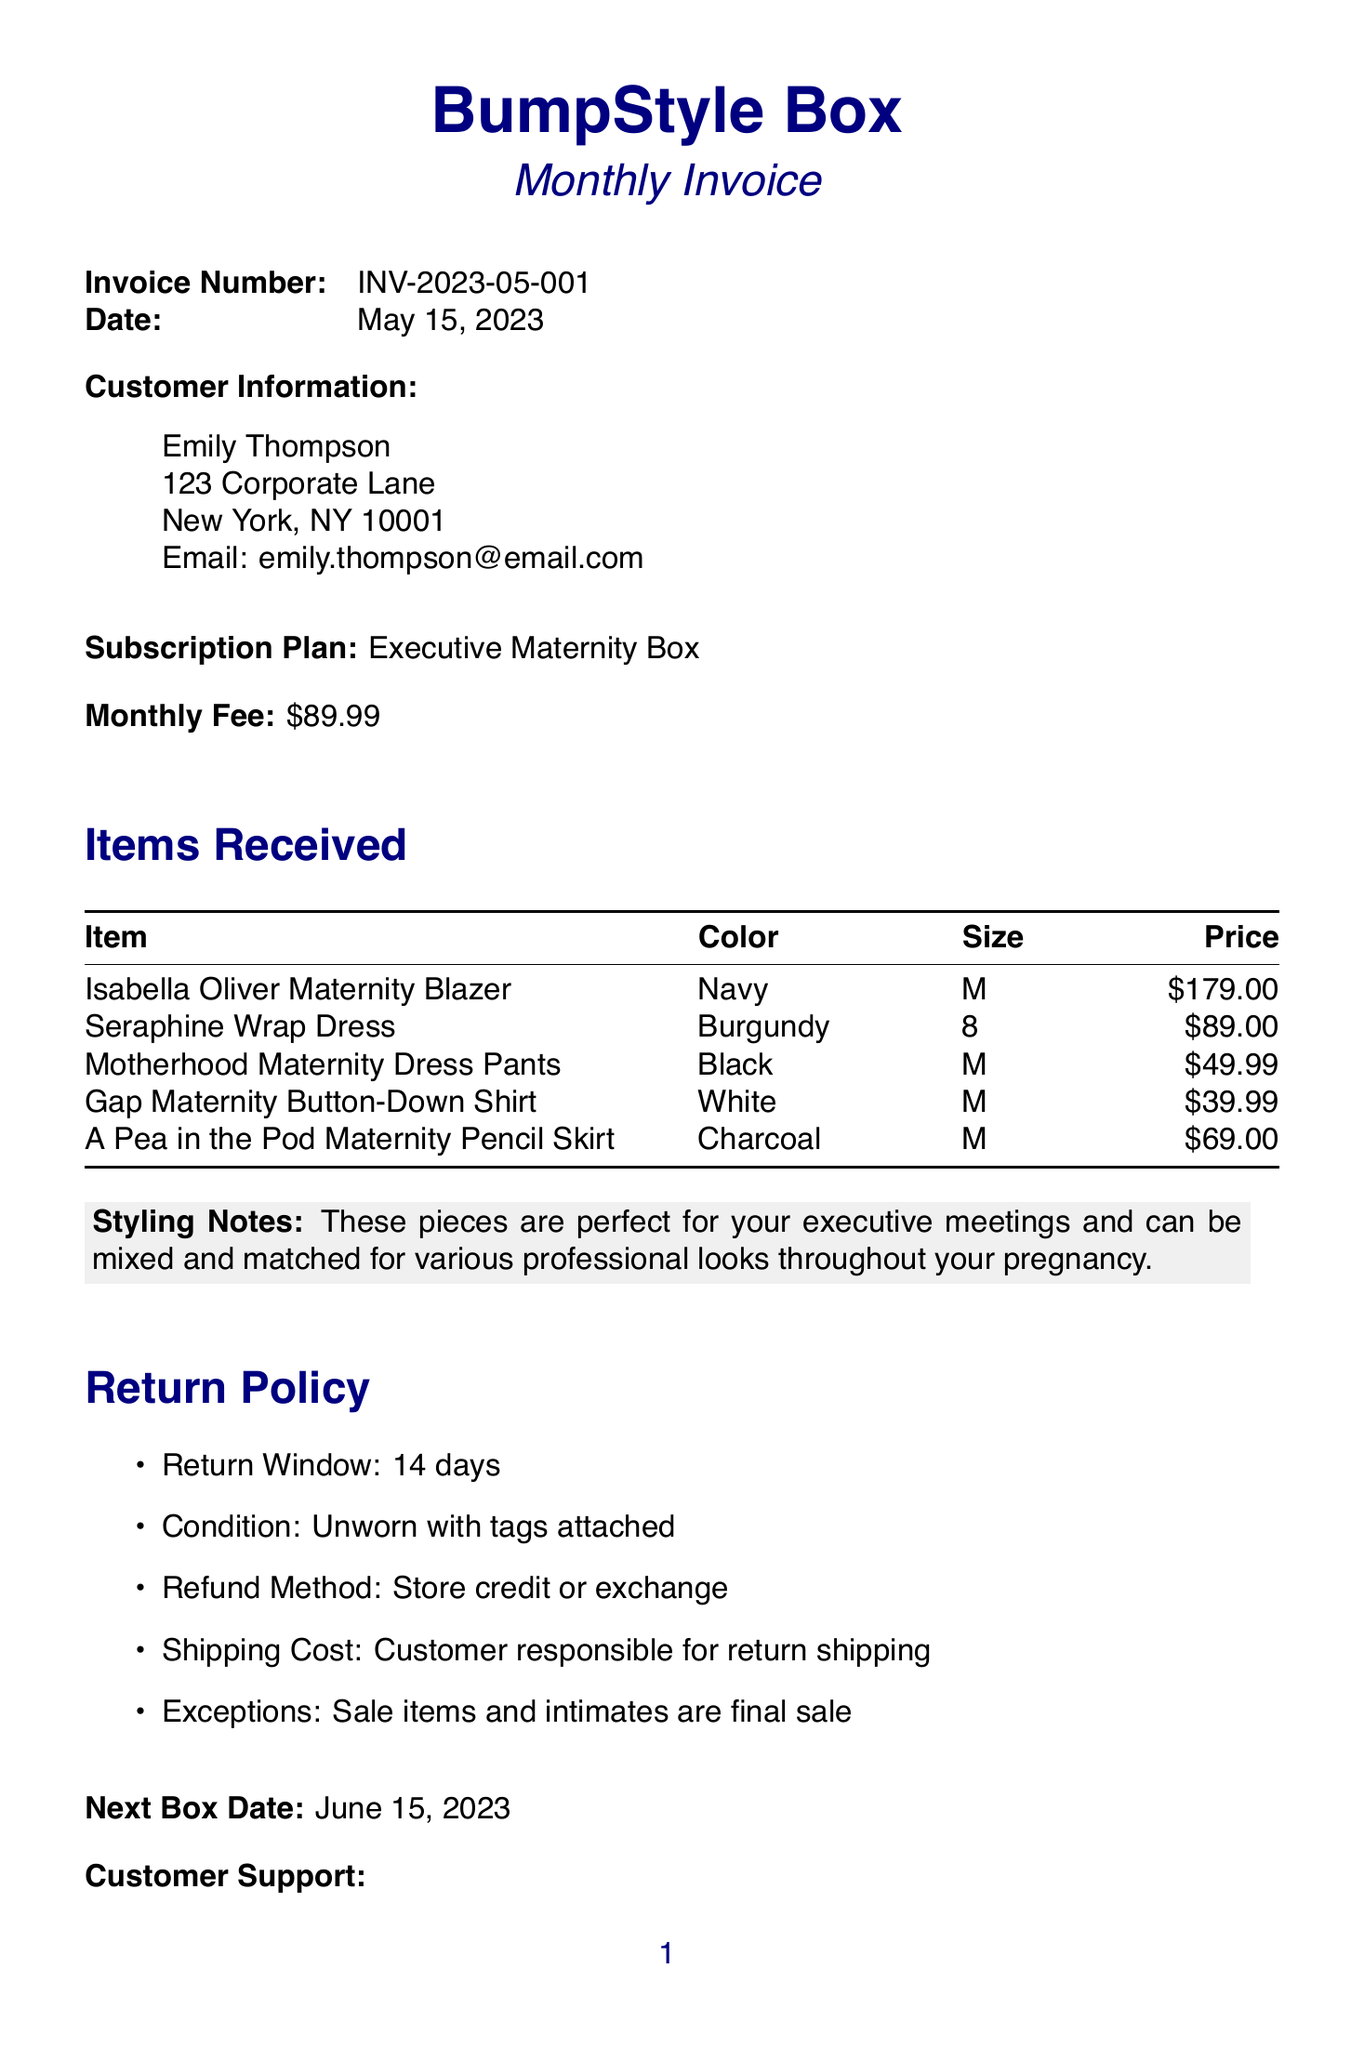What is the name of the company? The name of the company is located at the top of the document.
Answer: BumpStyle Box What is the invoice number? The invoice number can be found close to the document header.
Answer: INV-2023-05-001 What is the total monthly fee for the subscription? The monthly fee is stated in the invoice under the subscription plan section.
Answer: 89.99 How many items were received in this invoice? The number of items received can be counted from the items list in the document.
Answer: 5 What is the return window for items? The return window is specified in the return policy section of the document.
Answer: 14 days What is the contact email for customer support? The contact email can be found in the customer support section of the invoice.
Answer: support@bumpstylebox.com What is the refund method for returns? The refund method is mentioned in the return policy section under conditions for returns.
Answer: Store credit or exchange What is the next box date? The next box date is listed towards the end of the document.
Answer: June 15, 2023 What is a special offer mentioned in the invoice? The special offer is included at the bottom of the invoice.
Answer: Refer a colleague and receive 20% off your next box! 